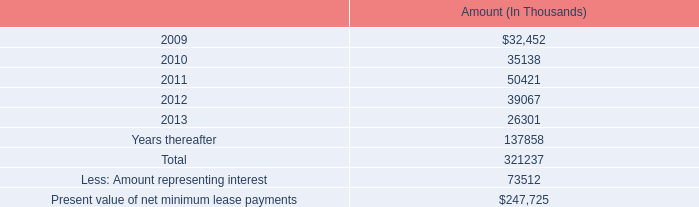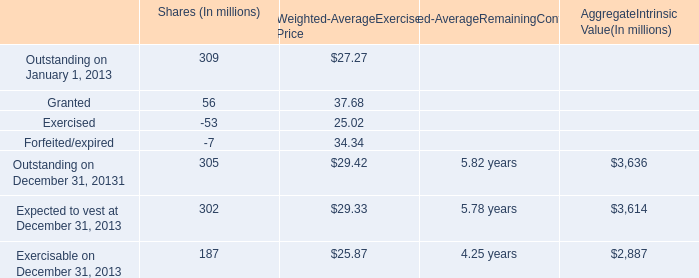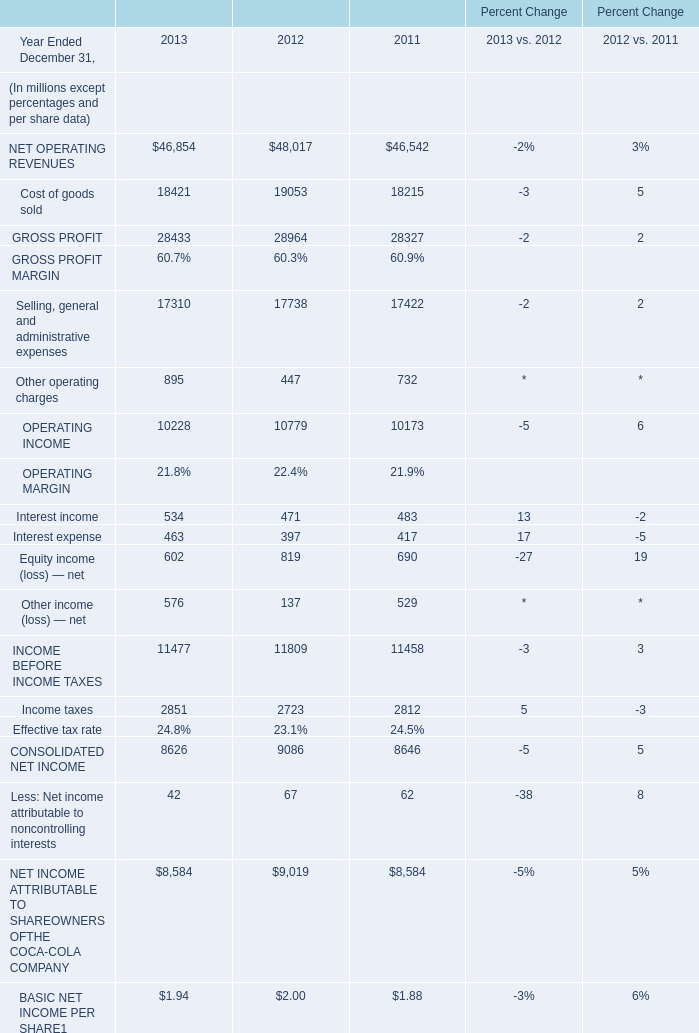not including years 'thereafter' , what is the total lease payments ? ( in $ thousands ) 
Computations: (321237 - 137858)
Answer: 183379.0. 